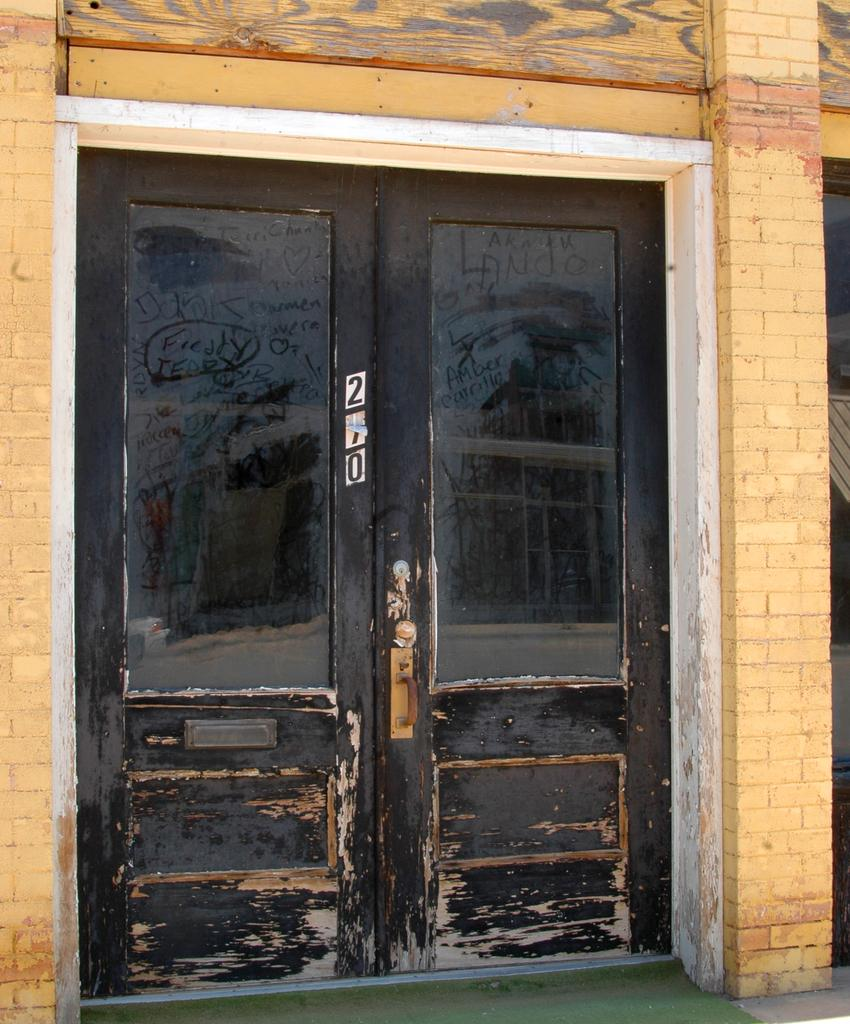What is the color of the door in the image? The door in the image is black with a white border. What is the color of the wall in the image? The wall in the image is big and cream-colored. What is written or displayed on the door in the image? There are numbers on the door in the image. What type of flooring is present in the image? There is a green carpet on the floor in the image. What type of stocking is hanging on the door in the image? There is no stocking present on the door in the image. Can you see an airplane flying in the background of the image? There is no airplane visible in the image; it only features a door, a wall, numbers, and a green carpet. 